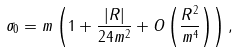<formula> <loc_0><loc_0><loc_500><loc_500>\sigma _ { 0 } = m \left ( 1 + \frac { | R | } { 2 4 m ^ { 2 } } + O \left ( \frac { R ^ { 2 } } { m ^ { 4 } } \right ) \right ) ,</formula> 